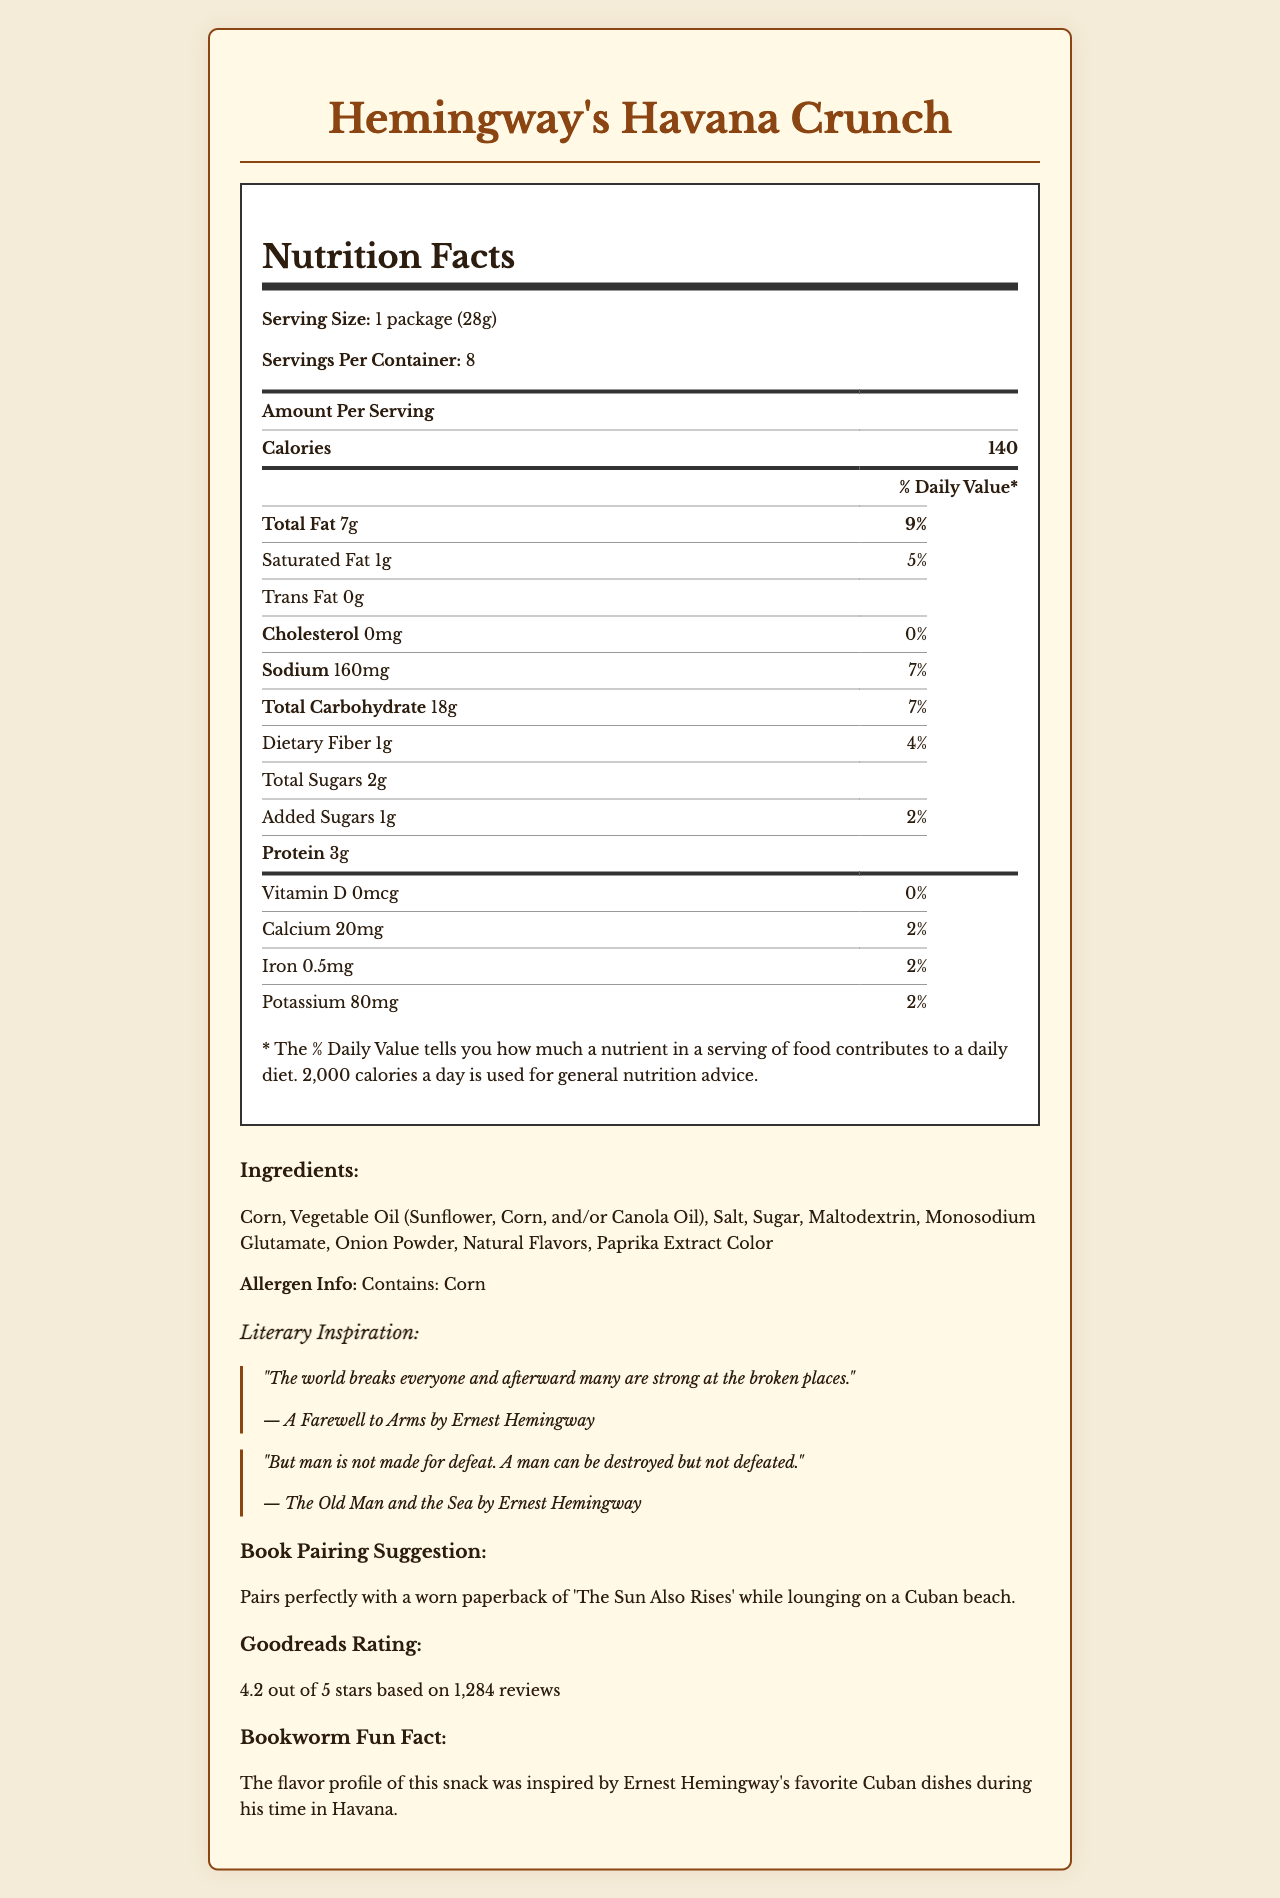what is the serving size of Hemingway's Havana Crunch? The serving size is indicated as "1 package (28g)" in the document.
Answer: 1 package (28g) how many calories are there per serving? The document shows that each serving has 140 calories.
Answer: 140 what is the total fat content per serving? The total fat content per serving is noted as 7g.
Answer: 7g what is the daily value percentage of sodium in each serving? The daily value percentage for sodium per serving is 7%.
Answer: 7% how much protein does each serving contain? Each serving contains 3g of protein.
Answer: 3g what are the primary ingredients in Hemingway's Havana Crunch? A. Vegetables, Salt, Sugar B. Corn, Vegetable Oil, Salt C. Wheat, Vegetable Oil, Sugar D. Corn, Milk, Sugar The primary ingredients listed are Corn, Vegetable Oil (Sunflower, Corn, and/or Canola Oil), and Salt.
Answer: B. Corn, Vegetable Oil, Salt which vitamin has the highest daily value percentage per serving? I. Vitamin D II. Calcium III. Iron IV. Potassium The daily value for Iron is 2%, which is the highest among the vitamins listed.
Answer: III. Iron is there any cholesterol in the snack? The cholesterol content is listed as 0mg, which means there is none.
Answer: No what are the literary quotes included on the document? The document contains these quotes from Ernest Hemingway's works.
Answer: "The world breaks everyone and afterward many are strong at the broken places." and "But man is not made for defeat. A man can be destroyed but not defeated." what is the rating of Hemingway's Havana Crunch on Goodreads? The Goodreads rating given is 4.2 out of 5 stars.
Answer: 4.2 out of 5 stars what is the flavor profile of the snack inspired by? The document states that the flavor profile is inspired by Ernest Hemingway's favorite Cuban dishes.
Answer: Ernest Hemingway's favorite Cuban dishes during his time in Havana if I wanted a snack to pair with my book 'The Sun Also Rises,' would Hemingway's Havana Crunch be a good choice? The document suggests Hemingway's Havana Crunch pairs perfectly with 'The Sun Also Rises.'
Answer: Yes what is the total carbohydrate content per serving? The total carbohydrate content per serving is 18g.
Answer: 18g describe the main idea of the document. This document offers a comprehensive overview of the Hemingway's Havana Crunch snack, combining nutritional data with literary inspirations to appeal to book lovers.
Answer: The document provides detailed nutritional information about the literary-themed snack Hemingway's Havana Crunch, including serving size, ingredients, and daily values of various nutrients. It also features literary quotes from Ernest Hemingway, a book pairing suggestion, Goodreads rating, and a fun fact about the flavor inspiration. which oil is not listed as an ingredient in Hemingway's Havana Crunch? A. Sunflower Oil B. Corn Oil C. Olive Oil D. Canola Oil The document lists Sunflower, Corn, and/or Canola Oil but does not mention Olive Oil.
Answer: C. Olive Oil how much added sugar is in each serving? The amount of added sugar per serving is listed as 1g.
Answer: 1g what quote was sourced from 'The Old Man and the Sea'? The quote from 'The Old Man and the Sea' is "But man is not made for defeat. A man can be destroyed but not defeated."
Answer: "But man is not made for defeat. A man can be destroyed but not defeated." how many servings are there per container? The document states that there are 8 servings per container.
Answer: 8 is there any information on how much Vitamin C is in the snack? The document does not provide any details on Vitamin C content.
Answer: Not enough information 